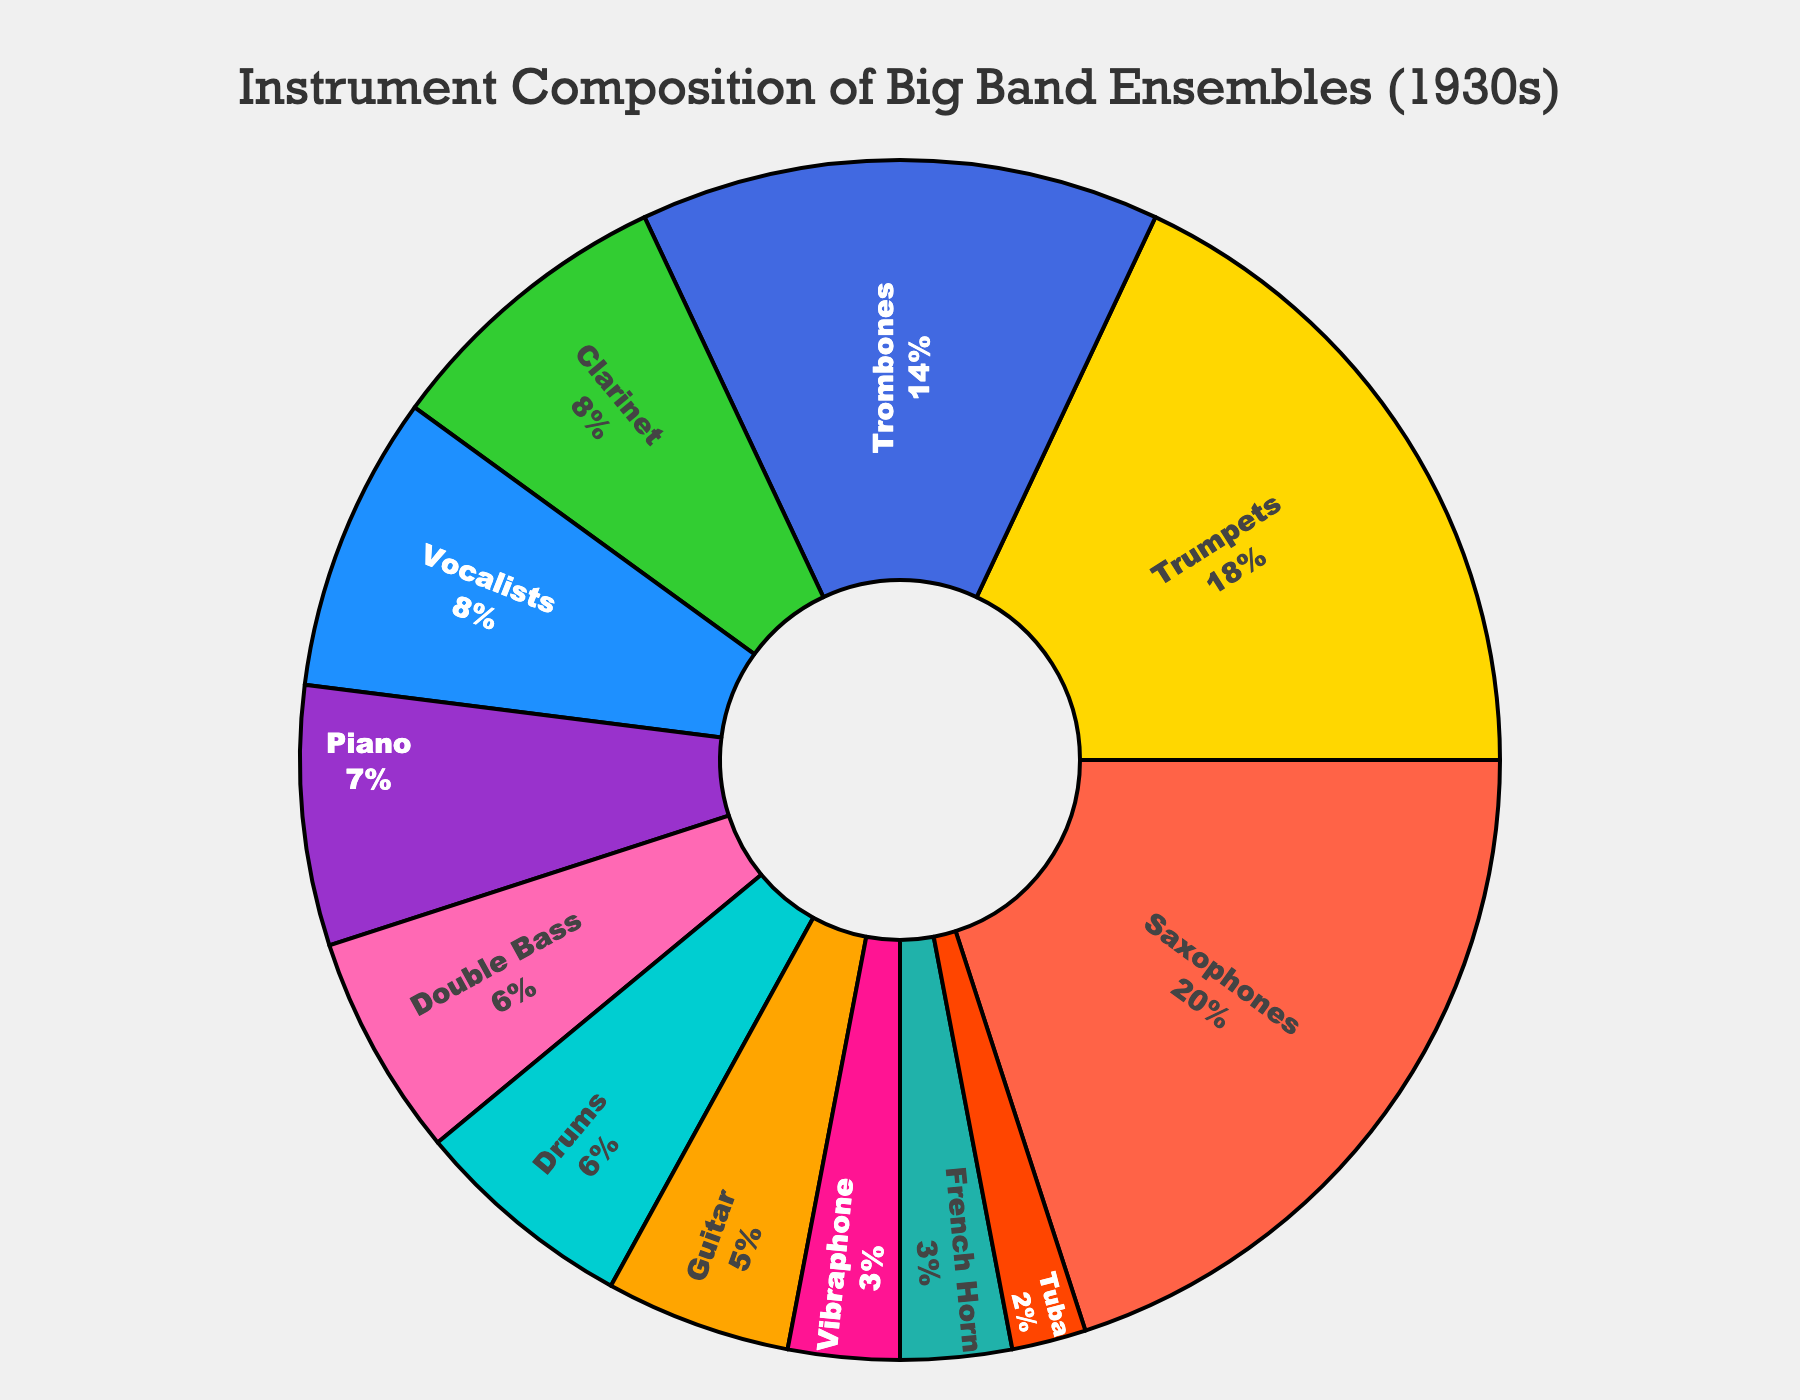What percentage of big band ensembles in the 1930s were made up of reed instruments (Saxophones and Clarinet combined)? First, find the percentage for Saxophones (20%) and the percentage for Clarinet (8%). Add these percentages together: 20% + 8% = 28%.
Answer: 28% Which instrument had a higher percentage, Trombones or Vocalists? Compare the percentage values of Trombones (14%) and Vocalists (8%). Since 14% is greater than 8%, Trombones had a higher percentage.
Answer: Trombones How many instruments have a composition percentage less than 10%? Count the instruments with percentages below 10%: Clarinet (8%), Piano (7%), Double Bass (6%), Drums (6%), Guitar (5%), Vibraphone (3%), French Horn (3%), and Tuba (2%). There are 8 such instruments.
Answer: 8 What is the difference in percentage between the instrument with the highest composition and the instrument with the lowest composition? Identify the highest percentage (Saxophones, 20%) and the lowest percentage (Tuba, 2%). Subtract the lowest from the highest: 20% - 2% = 18%.
Answer: 18% Are there any instruments that have the same percentage composition? If so, which ones? Compare the percentages: Clarinet (8%) and Vocalists (8%), Drums (6%) and Double Bass (6%), French Horn (3%) and Vibraphone (3%). These pairs have the same percentages.
Answer: Clarinet and Vocalists, Drums and Double Bass, French Horn and Vibraphone Which instrument is represented by the yellow slice? The yellow slice represents the Trumpets.
Answer: Trumpets What is the total percentage of rhythm section instruments (Piano, Double Bass, Drums, and Guitar combined)? Sum the percentages: Piano (7%) + Double Bass (6%) + Drums (6%) + Guitar (5%) = 24%.
Answer: 24% By how many percentage points do trumpets exceed trombones? Subtract Trombone's percentage from Trumpet's percentage: 18% - 14% = 4%.
Answer: 4% What percentage of the ensemble is made up of instruments other than Saxophones, Trumpets, and Trombones? Calculate the total percentage of Saxophones, Trumpets, and Trombones: 20% + 18% + 14% = 52%. Subtract this from 100%: 100% - 52% = 48%.
Answer: 48% 